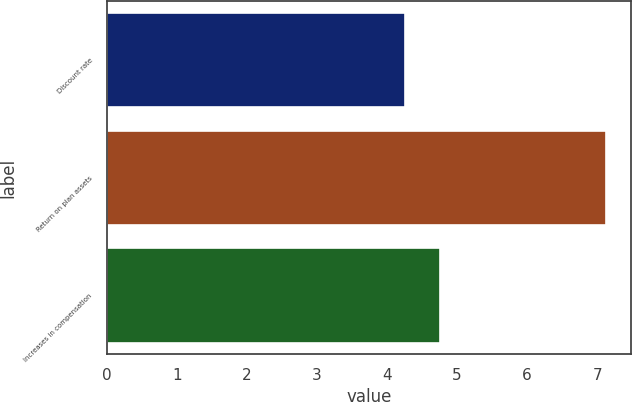Convert chart. <chart><loc_0><loc_0><loc_500><loc_500><bar_chart><fcel>Discount rate<fcel>Return on plan assets<fcel>Increases in compensation<nl><fcel>4.26<fcel>7.12<fcel>4.75<nl></chart> 